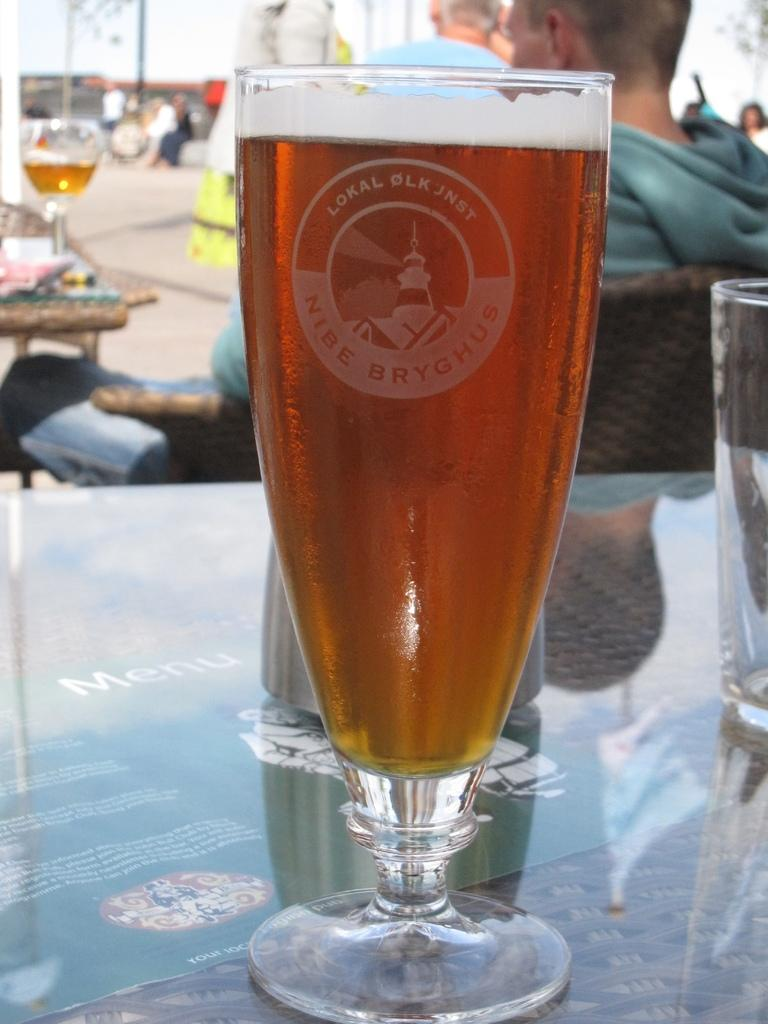Provide a one-sentence caption for the provided image. A tall glass of beer bears a lighthouse on its logo and the words Nibe Bryghus. 